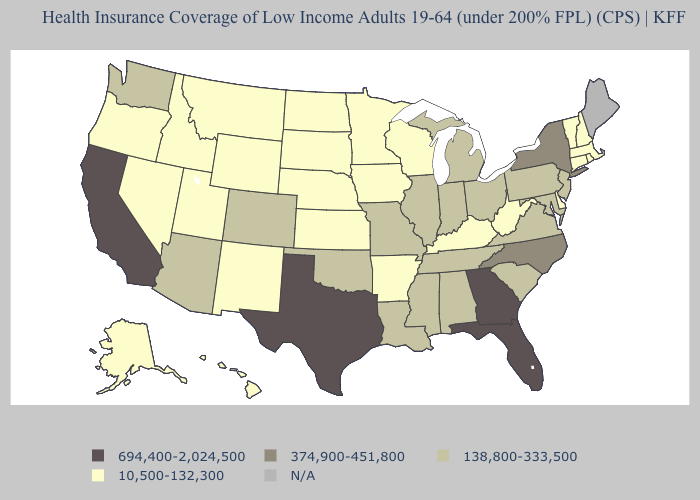Which states have the lowest value in the USA?
Keep it brief. Alaska, Arkansas, Connecticut, Delaware, Hawaii, Idaho, Iowa, Kansas, Kentucky, Massachusetts, Minnesota, Montana, Nebraska, Nevada, New Hampshire, New Mexico, North Dakota, Oregon, Rhode Island, South Dakota, Utah, Vermont, West Virginia, Wisconsin, Wyoming. Does Kentucky have the lowest value in the South?
Write a very short answer. Yes. Which states have the highest value in the USA?
Short answer required. California, Florida, Georgia, Texas. Does the first symbol in the legend represent the smallest category?
Be succinct. No. Does Montana have the highest value in the West?
Concise answer only. No. What is the value of Utah?
Quick response, please. 10,500-132,300. Name the states that have a value in the range 374,900-451,800?
Short answer required. New York, North Carolina. Name the states that have a value in the range 10,500-132,300?
Be succinct. Alaska, Arkansas, Connecticut, Delaware, Hawaii, Idaho, Iowa, Kansas, Kentucky, Massachusetts, Minnesota, Montana, Nebraska, Nevada, New Hampshire, New Mexico, North Dakota, Oregon, Rhode Island, South Dakota, Utah, Vermont, West Virginia, Wisconsin, Wyoming. What is the value of Alabama?
Answer briefly. 138,800-333,500. What is the lowest value in states that border South Carolina?
Quick response, please. 374,900-451,800. What is the value of Virginia?
Short answer required. 138,800-333,500. Among the states that border West Virginia , does Kentucky have the lowest value?
Short answer required. Yes. What is the value of Illinois?
Quick response, please. 138,800-333,500. Does Maryland have the highest value in the USA?
Concise answer only. No. Name the states that have a value in the range N/A?
Concise answer only. Maine. 